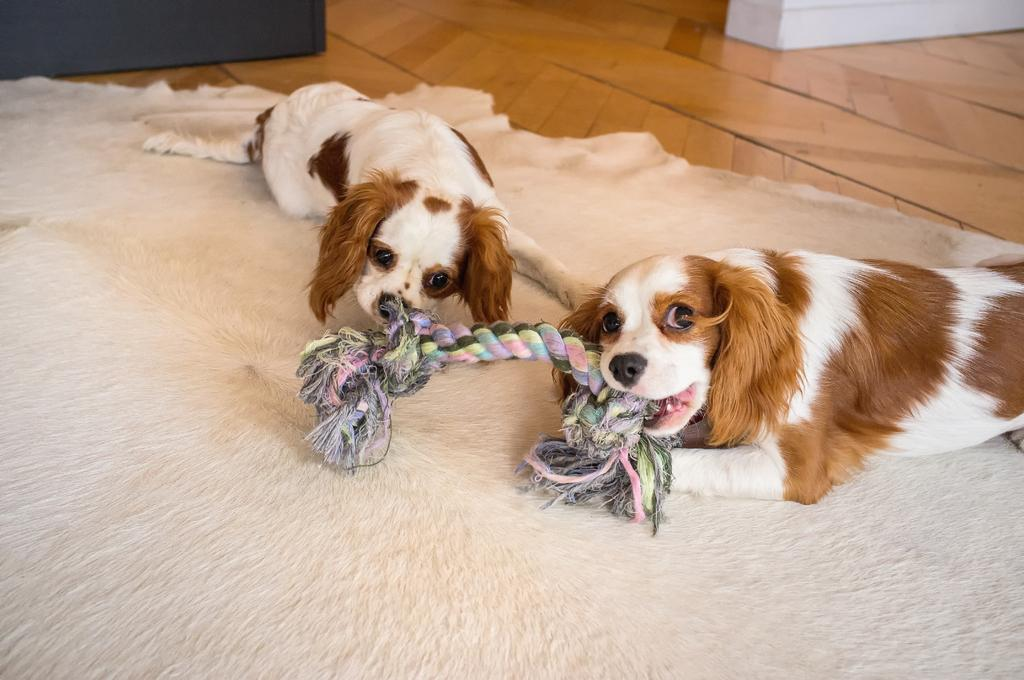What is located at the bottom of the image? There is a carpet at the bottom of the image. What can be seen in the middle of the image? There are dogs in the middle of the image. What note is the dog playing on the carpet in the image? There is no indication in the image that the dogs are playing a musical instrument or note. What type of scent can be detected from the dogs in the image? The image does not provide any information about the scent of the dogs. 